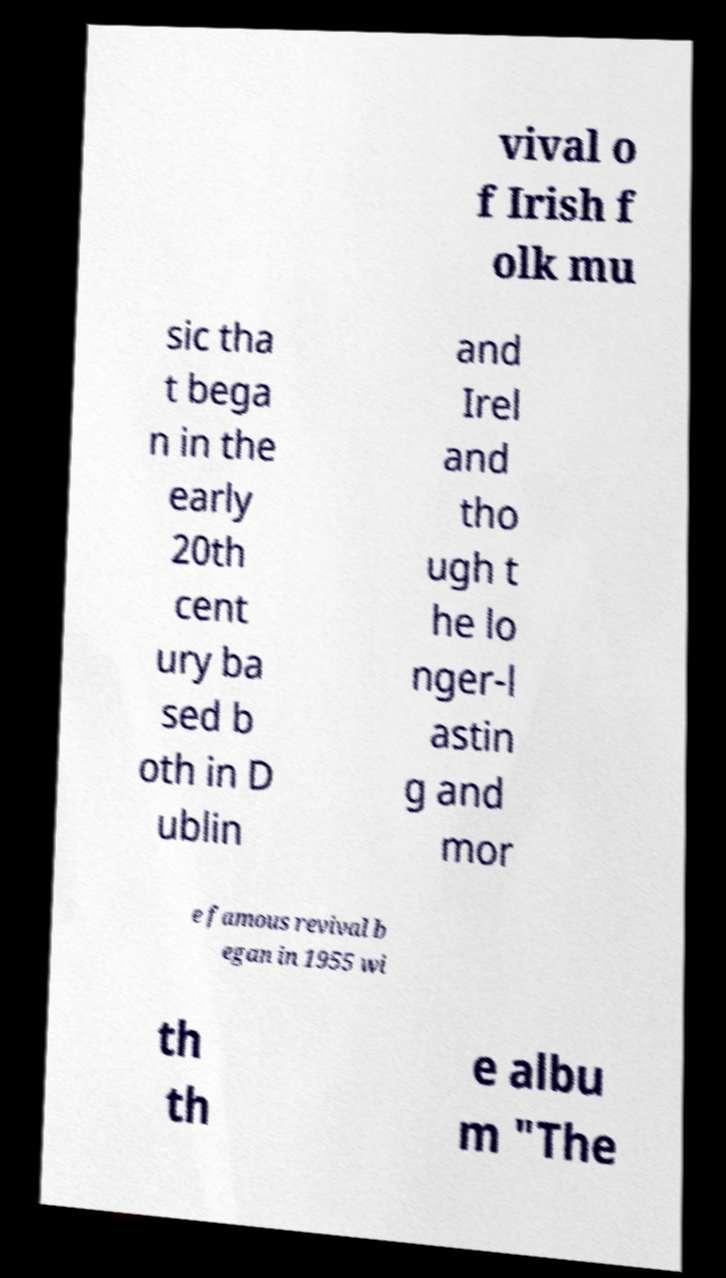Could you extract and type out the text from this image? vival o f Irish f olk mu sic tha t bega n in the early 20th cent ury ba sed b oth in D ublin and Irel and tho ugh t he lo nger-l astin g and mor e famous revival b egan in 1955 wi th th e albu m "The 